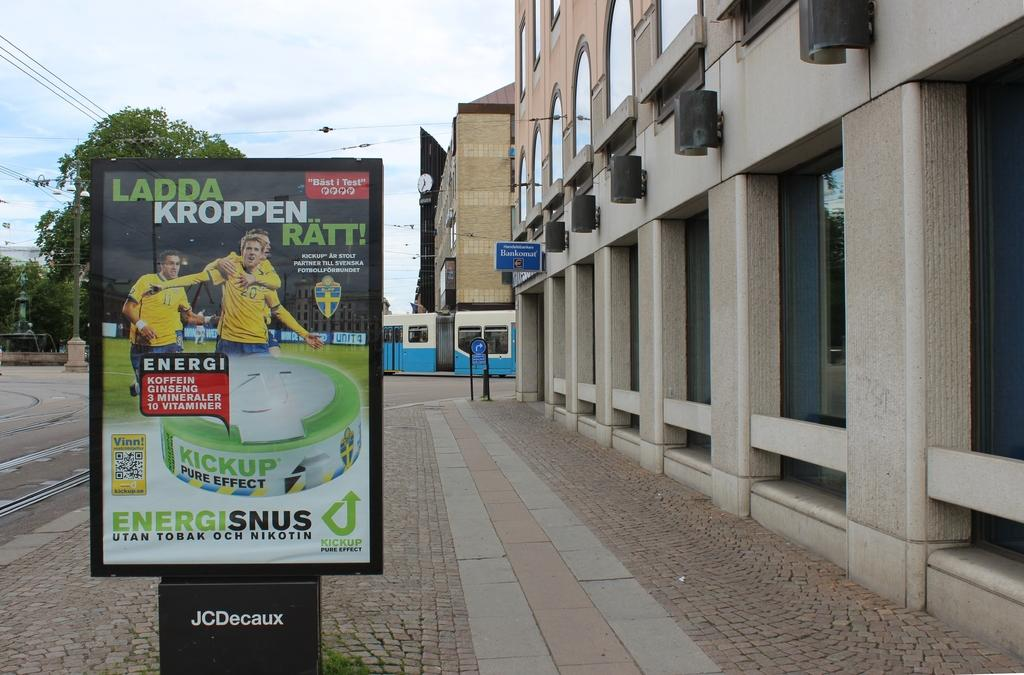<image>
Provide a brief description of the given image. a street with a billboard from JC Decaux for Ladda Kroppen Ratt 